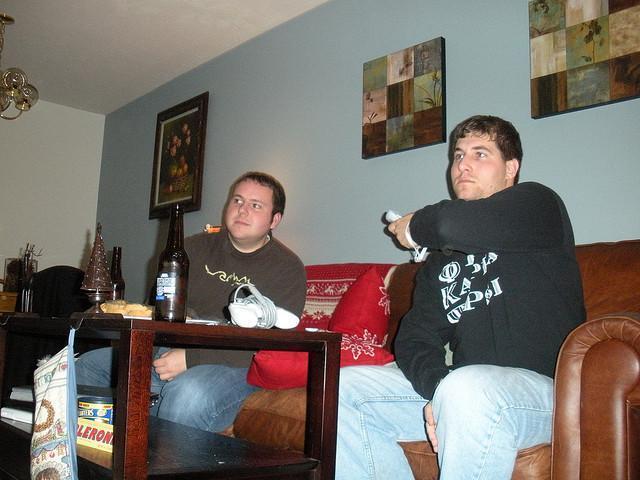How many things are hanging on the wall?
Give a very brief answer. 3. How many people are there?
Give a very brief answer. 2. 